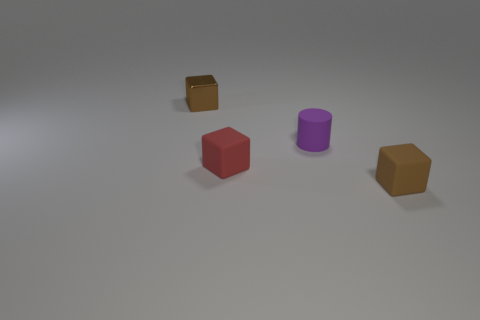What number of other objects are there of the same size as the cylinder?
Provide a succinct answer. 3. Are there any small matte cubes?
Offer a terse response. Yes. What is the size of the brown block on the right side of the small brown block that is to the left of the brown rubber thing?
Offer a very short reply. Small. There is a tiny matte block that is in front of the red rubber cube; does it have the same color as the thing that is behind the purple cylinder?
Provide a succinct answer. Yes. The thing that is to the left of the small purple rubber thing and behind the red matte block is what color?
Make the answer very short. Brown. How many other things are there of the same shape as the brown rubber object?
Give a very brief answer. 2. What color is the rubber cylinder that is the same size as the red thing?
Provide a succinct answer. Purple. The matte block right of the purple thing is what color?
Provide a short and direct response. Brown. There is a brown thing behind the tiny brown rubber object; are there any brown blocks that are right of it?
Provide a succinct answer. Yes. There is a tiny red thing; is its shape the same as the small rubber object that is behind the tiny red cube?
Make the answer very short. No. 